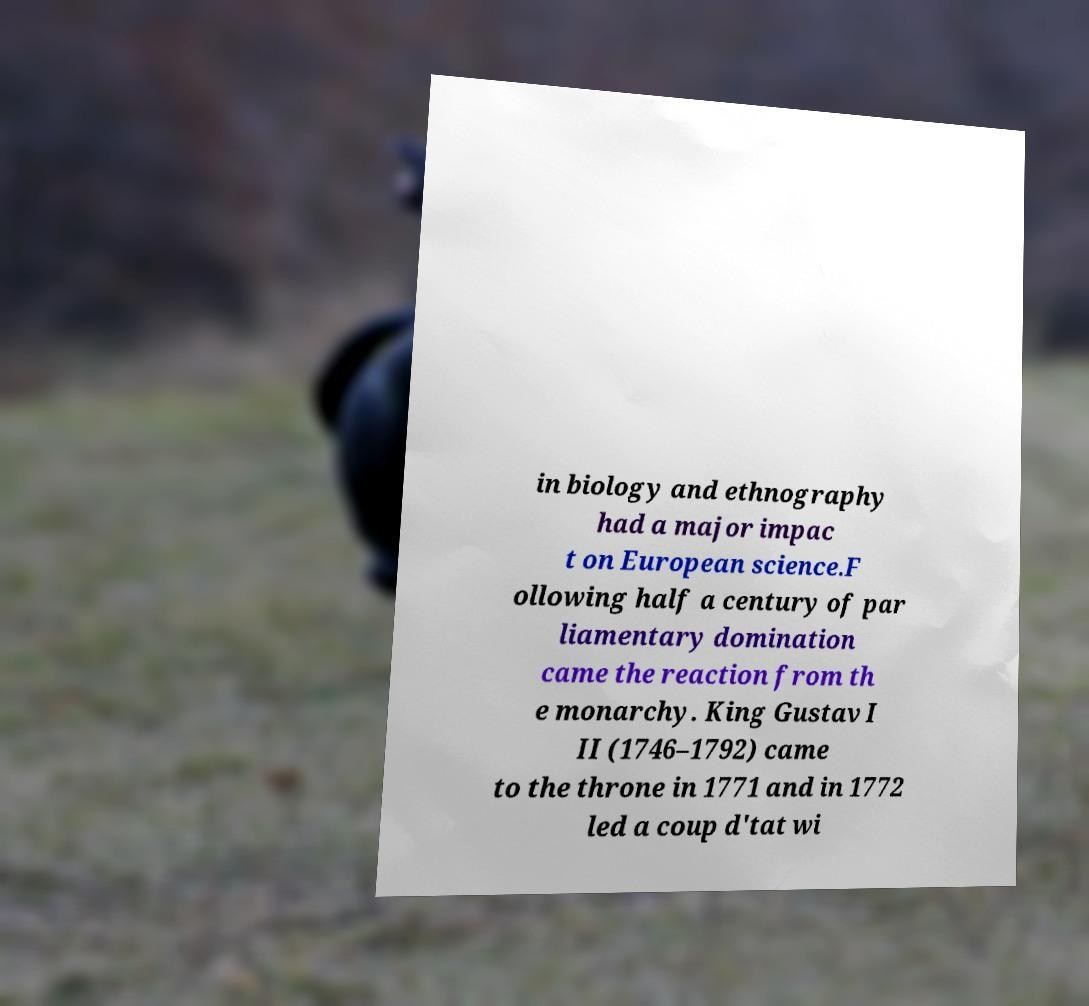For documentation purposes, I need the text within this image transcribed. Could you provide that? in biology and ethnography had a major impac t on European science.F ollowing half a century of par liamentary domination came the reaction from th e monarchy. King Gustav I II (1746–1792) came to the throne in 1771 and in 1772 led a coup d'tat wi 